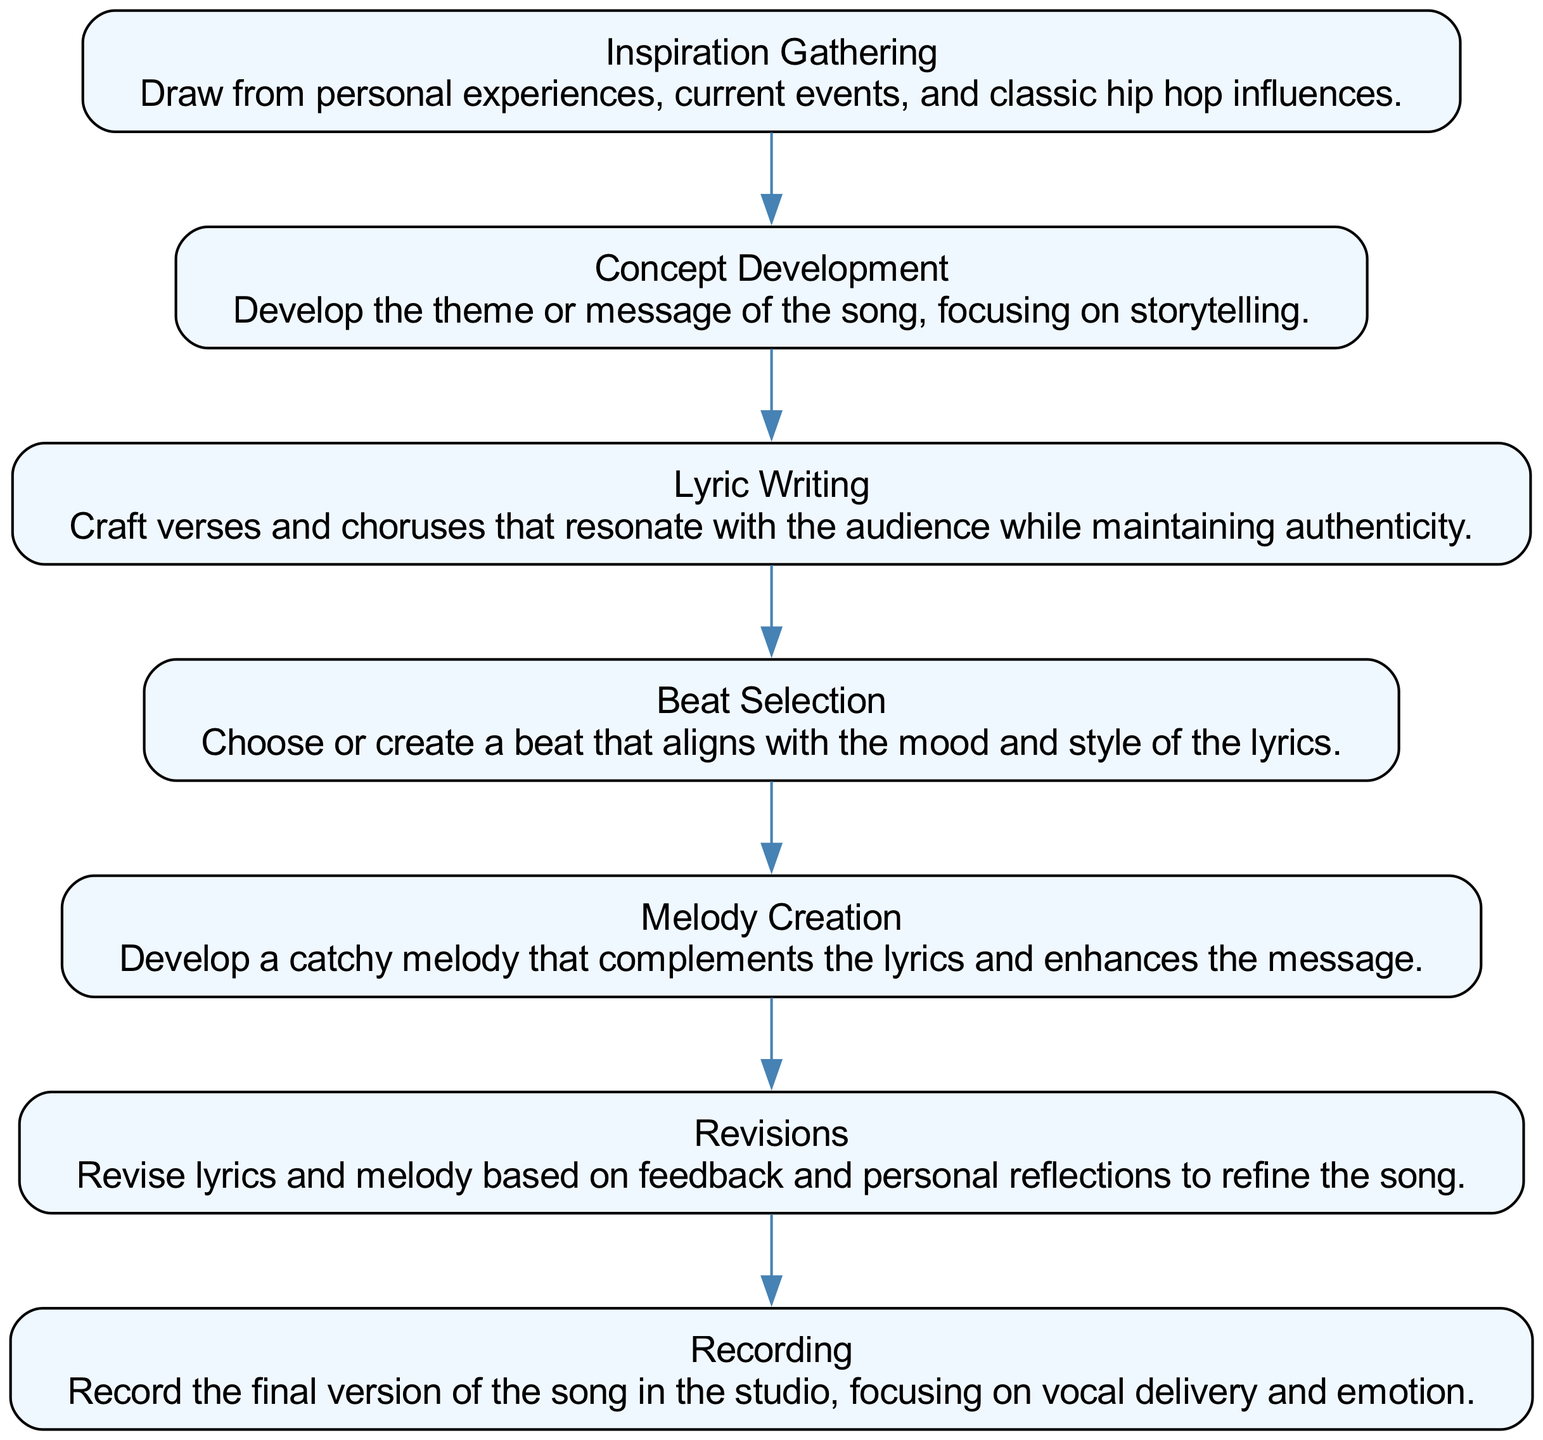What is the first step in the songwriting process? The first step listed in the diagram is "Inspiration Gathering." This can be found at the top of the flow chart, indicating where the process begins.
Answer: Inspiration Gathering How many steps are included in the songwriting process? Counting the steps in the flow chart, there are a total of seven steps shown in the progression.
Answer: Seven What step comes after "Lyric Writing"? The diagram shows that "Beat Selection" follows "Lyric Writing" in the sequence of steps. This can be seen in the flow from the previous node.
Answer: Beat Selection What is the last step in the songwriting process? "Recording" is displayed as the final step at the bottom of the flow chart, indicating the last action in the process.
Answer: Recording Which step focuses on improving the song based on feedback? The "Revisions" step directly addresses the process of assessing and improving the song according to feedback, indicating refinement.
Answer: Revisions How is "Melody Creation" related to "Beat Selection"? "Melody Creation" follows "Beat Selection" in the flow, suggesting that these steps are consecutive actions in the songwriting process.
Answer: Consecutive Identify the main focus of "Concept Development." The description for "Concept Development" highlights developing the theme or message of the song, emphasizing storytelling as the main focus.
Answer: Storytelling In which step do you select or create a beat? The "Beat Selection" step involves the actual process of choosing or creating a beat that fits the lyrics. This is explicitly stated in its description.
Answer: Beat Selection What activity follows "Inspiration Gathering"? The next step after "Inspiration Gathering" in the flow is "Concept Development," indicating a progression from gathering inspiration to forming a concept for the song.
Answer: Concept Development 